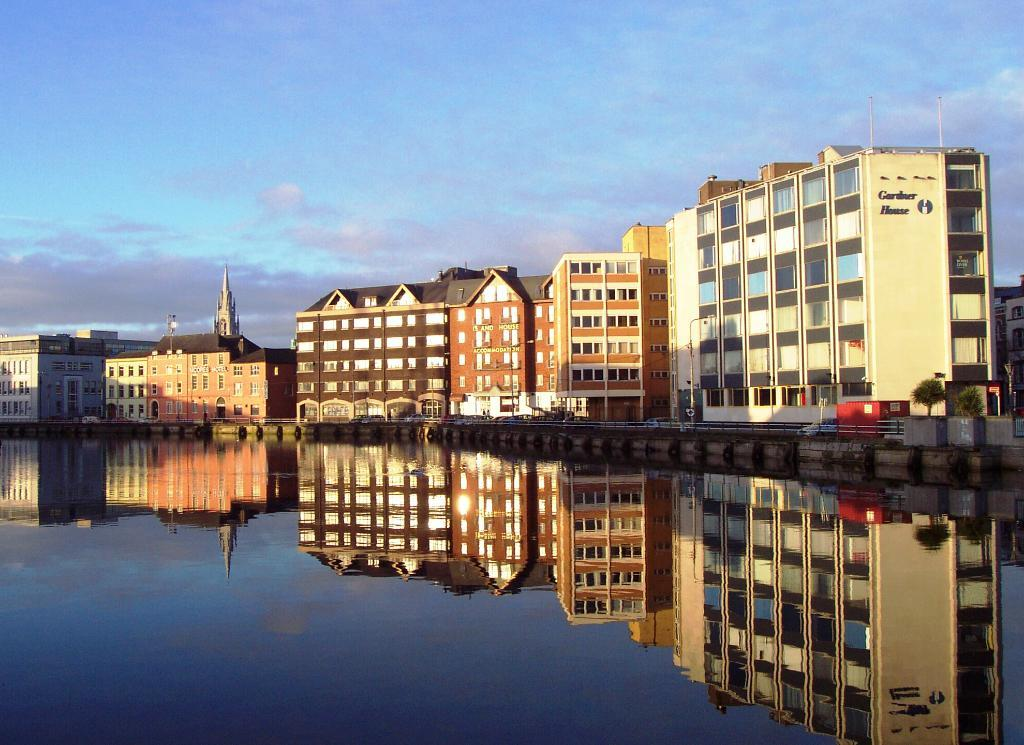What is present in the image that is not solid? There is water in the image. What does the water in the image reflect? The water reflects buildings in the image. What can be seen in the background of the image? There are buildings, plants, and the sky visible in the background of the image. What type of art can be seen in the image? There is no art present in the image; it features water, buildings, plants, and the sky. 